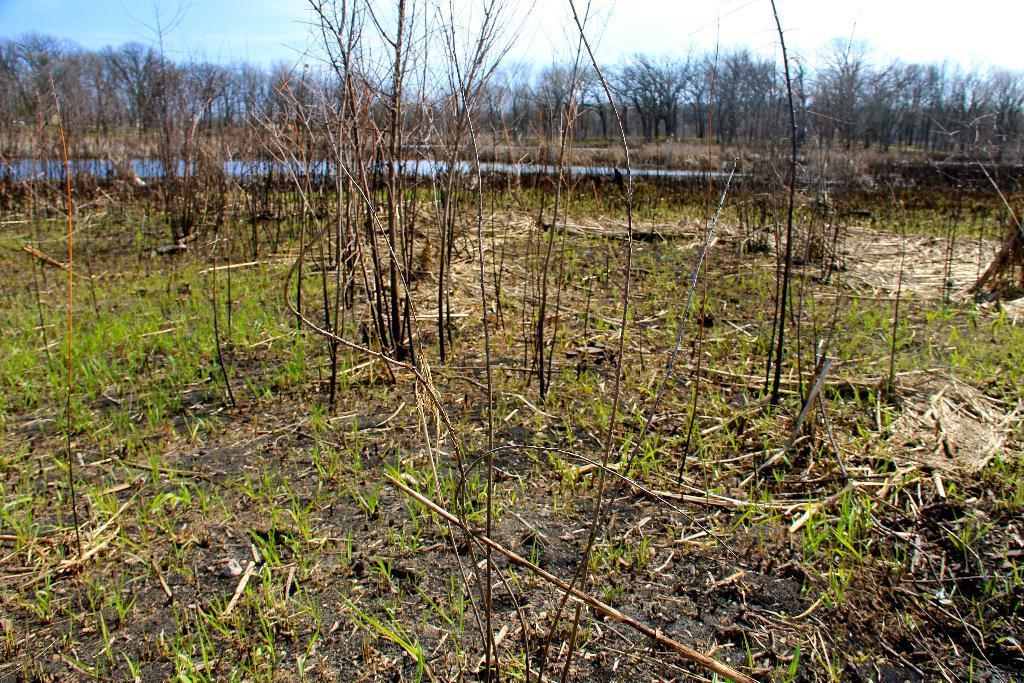Describe this image in one or two sentences. There are trees. On the ground there are plants. In the back there is water, sky and trees. 